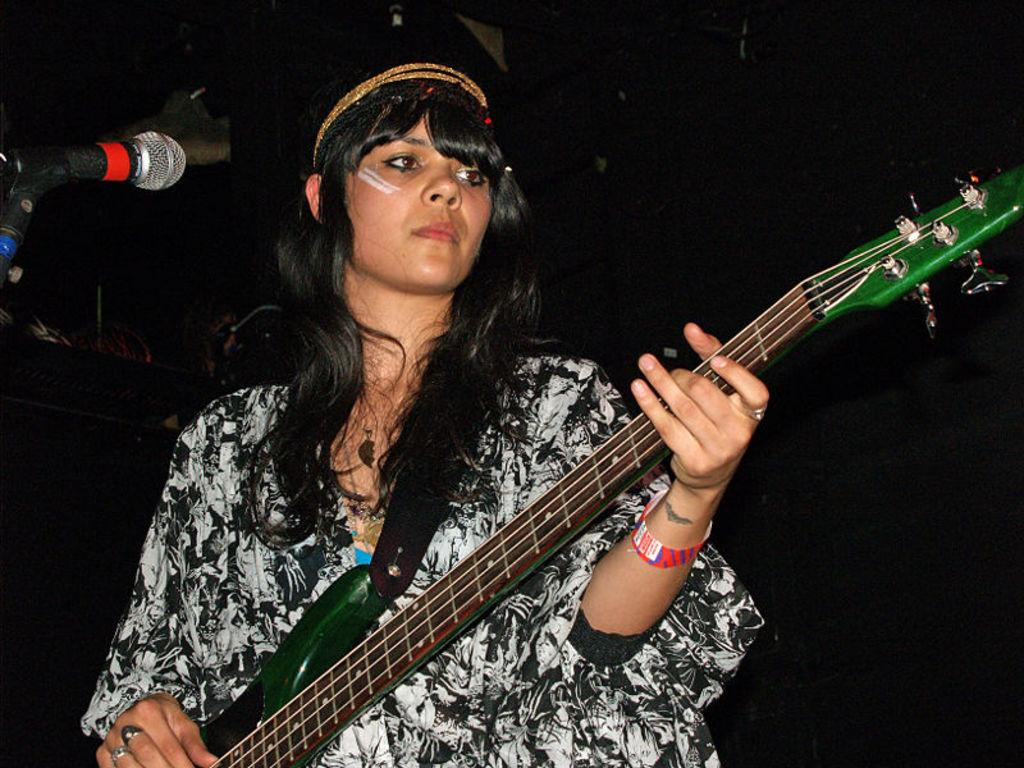What is the main subject of the image? There is a person in the image. What is the person doing in the image? The person is standing and holding a guitar. What object is in front of the person? There is a microphone in front of the person. How would you describe the background of the image? The background of the image is dark. How many beds can be seen in the image? There are no beds present in the image. What type of memory is being stored in the person's guitar? The image does not provide information about any memories being stored in the guitar. 